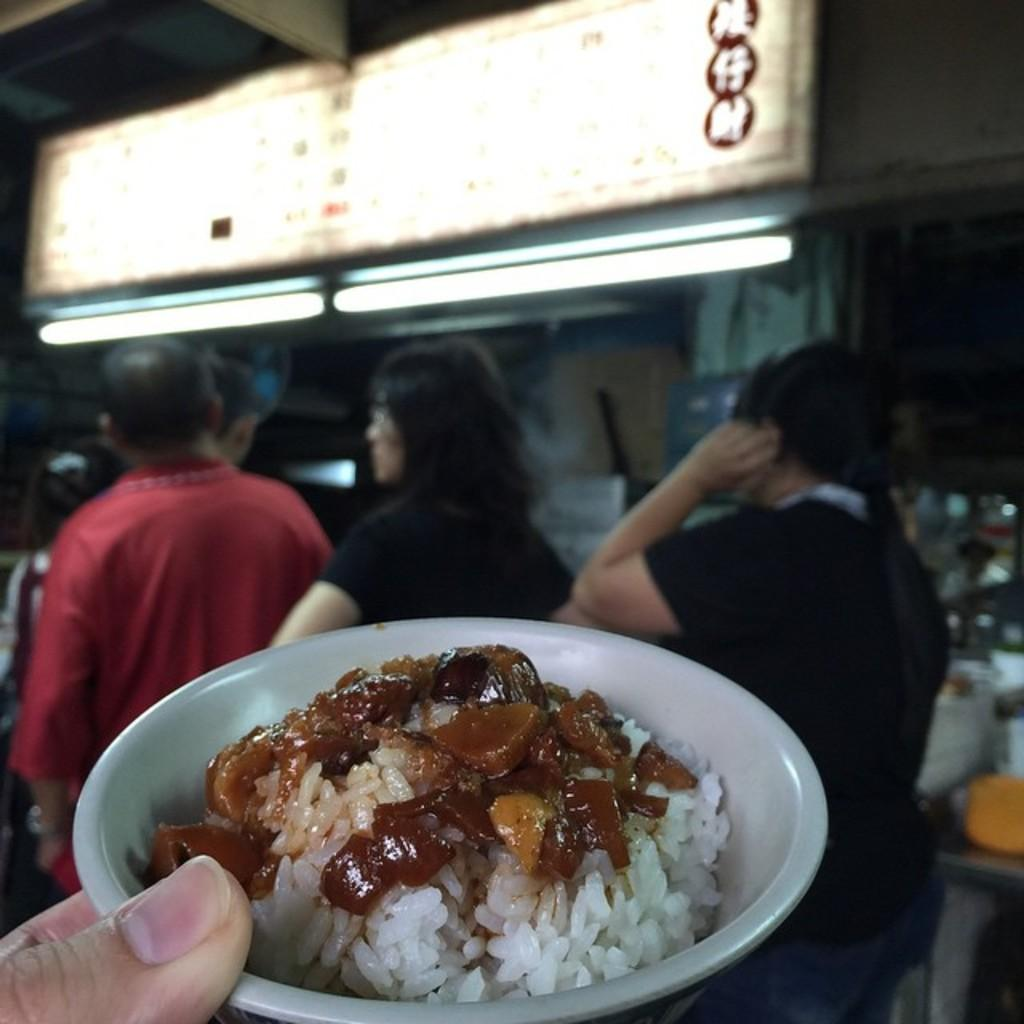What is the person holding in their fingers in the image? There is a food item in a bowl in the person's fingers. What can be seen in the background of the image? There are people, lights, a hoarding, and other objects visible in the background. What type of sand can be seen in the person's fingers in the image? There is no sand present in the image; the person is holding a food item in a bowl. 